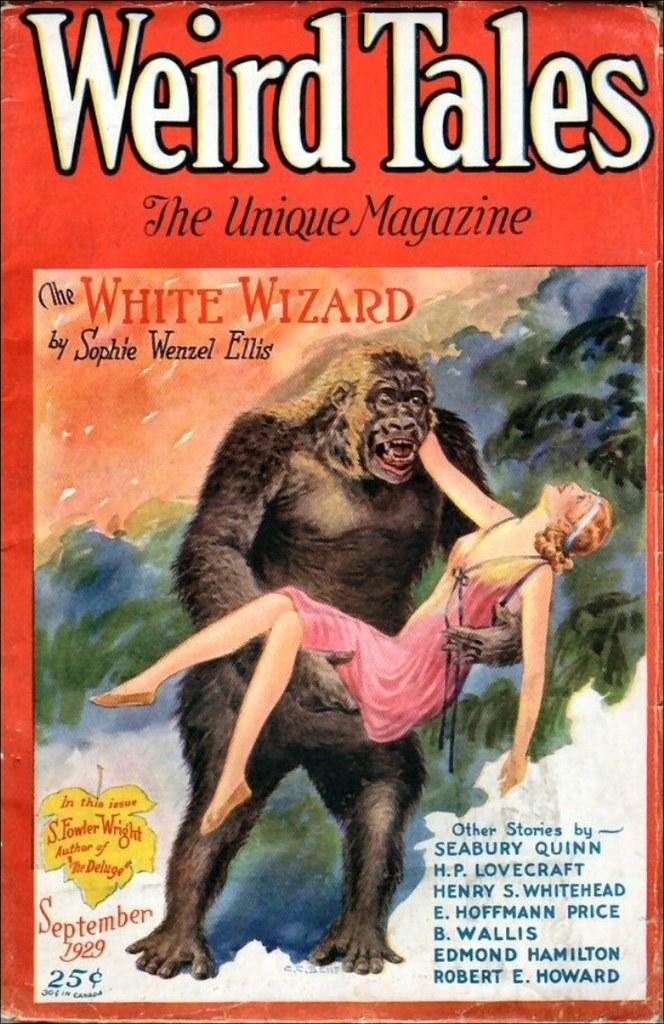What is featured on the poster in the image? The poster contains a picture of an ape holding a woman. What else can be seen on the poster besides the image? There is text written on the poster. What type of tree can be seen growing in the middle of the poster? There is no tree present in the image; the poster features a picture of an ape holding a woman and text. What appliance is being used by the ape in the image? The image does not depict an ape using any appliance; it shows an ape holding a woman. 